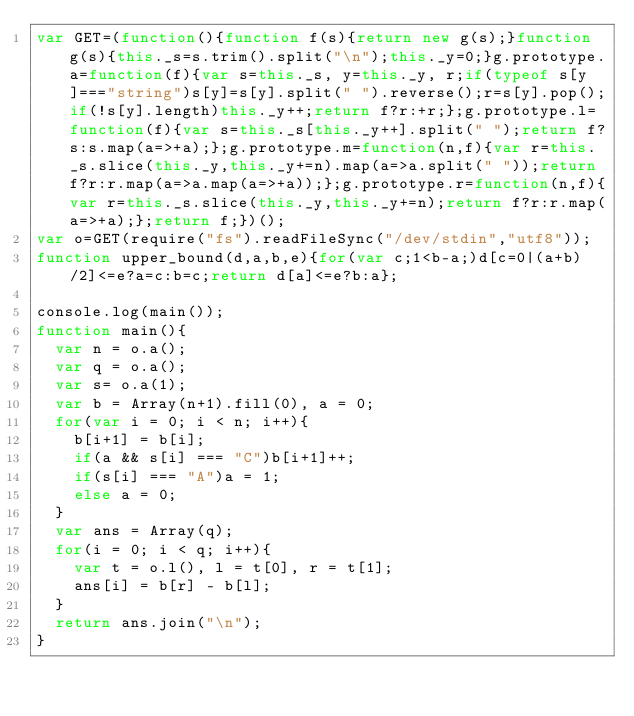Convert code to text. <code><loc_0><loc_0><loc_500><loc_500><_JavaScript_>var GET=(function(){function f(s){return new g(s);}function g(s){this._s=s.trim().split("\n");this._y=0;}g.prototype.a=function(f){var s=this._s, y=this._y, r;if(typeof s[y]==="string")s[y]=s[y].split(" ").reverse();r=s[y].pop();if(!s[y].length)this._y++;return f?r:+r;};g.prototype.l=function(f){var s=this._s[this._y++].split(" ");return f?s:s.map(a=>+a);};g.prototype.m=function(n,f){var r=this._s.slice(this._y,this._y+=n).map(a=>a.split(" "));return f?r:r.map(a=>a.map(a=>+a));};g.prototype.r=function(n,f){var r=this._s.slice(this._y,this._y+=n);return f?r:r.map(a=>+a);};return f;})();
var o=GET(require("fs").readFileSync("/dev/stdin","utf8"));
function upper_bound(d,a,b,e){for(var c;1<b-a;)d[c=0|(a+b)/2]<=e?a=c:b=c;return d[a]<=e?b:a};

console.log(main());
function main(){
  var n = o.a();
  var q = o.a();
  var s= o.a(1);
  var b = Array(n+1).fill(0), a = 0;
  for(var i = 0; i < n; i++){
    b[i+1] = b[i];
    if(a && s[i] === "C")b[i+1]++;
    if(s[i] === "A")a = 1;
    else a = 0;
  }
  var ans = Array(q);
  for(i = 0; i < q; i++){
    var t = o.l(), l = t[0], r = t[1];
    ans[i] = b[r] - b[l];
  }
  return ans.join("\n");
}</code> 